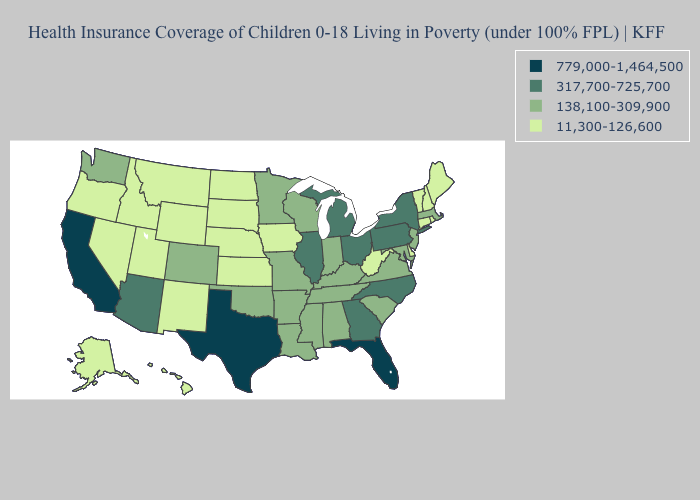Among the states that border Tennessee , which have the highest value?
Quick response, please. Georgia, North Carolina. Does California have the highest value in the USA?
Give a very brief answer. Yes. Does Utah have the lowest value in the USA?
Be succinct. Yes. Name the states that have a value in the range 317,700-725,700?
Keep it brief. Arizona, Georgia, Illinois, Michigan, New York, North Carolina, Ohio, Pennsylvania. Does Georgia have the same value as North Carolina?
Be succinct. Yes. Does the first symbol in the legend represent the smallest category?
Answer briefly. No. Which states have the lowest value in the USA?
Concise answer only. Alaska, Connecticut, Delaware, Hawaii, Idaho, Iowa, Kansas, Maine, Montana, Nebraska, Nevada, New Hampshire, New Mexico, North Dakota, Oregon, Rhode Island, South Dakota, Utah, Vermont, West Virginia, Wyoming. Does Massachusetts have a lower value than Mississippi?
Write a very short answer. No. What is the value of Nebraska?
Keep it brief. 11,300-126,600. Does Virginia have the highest value in the USA?
Give a very brief answer. No. What is the value of Utah?
Keep it brief. 11,300-126,600. Does Texas have the highest value in the USA?
Quick response, please. Yes. Name the states that have a value in the range 779,000-1,464,500?
Be succinct. California, Florida, Texas. Name the states that have a value in the range 11,300-126,600?
Quick response, please. Alaska, Connecticut, Delaware, Hawaii, Idaho, Iowa, Kansas, Maine, Montana, Nebraska, Nevada, New Hampshire, New Mexico, North Dakota, Oregon, Rhode Island, South Dakota, Utah, Vermont, West Virginia, Wyoming. Name the states that have a value in the range 779,000-1,464,500?
Give a very brief answer. California, Florida, Texas. 